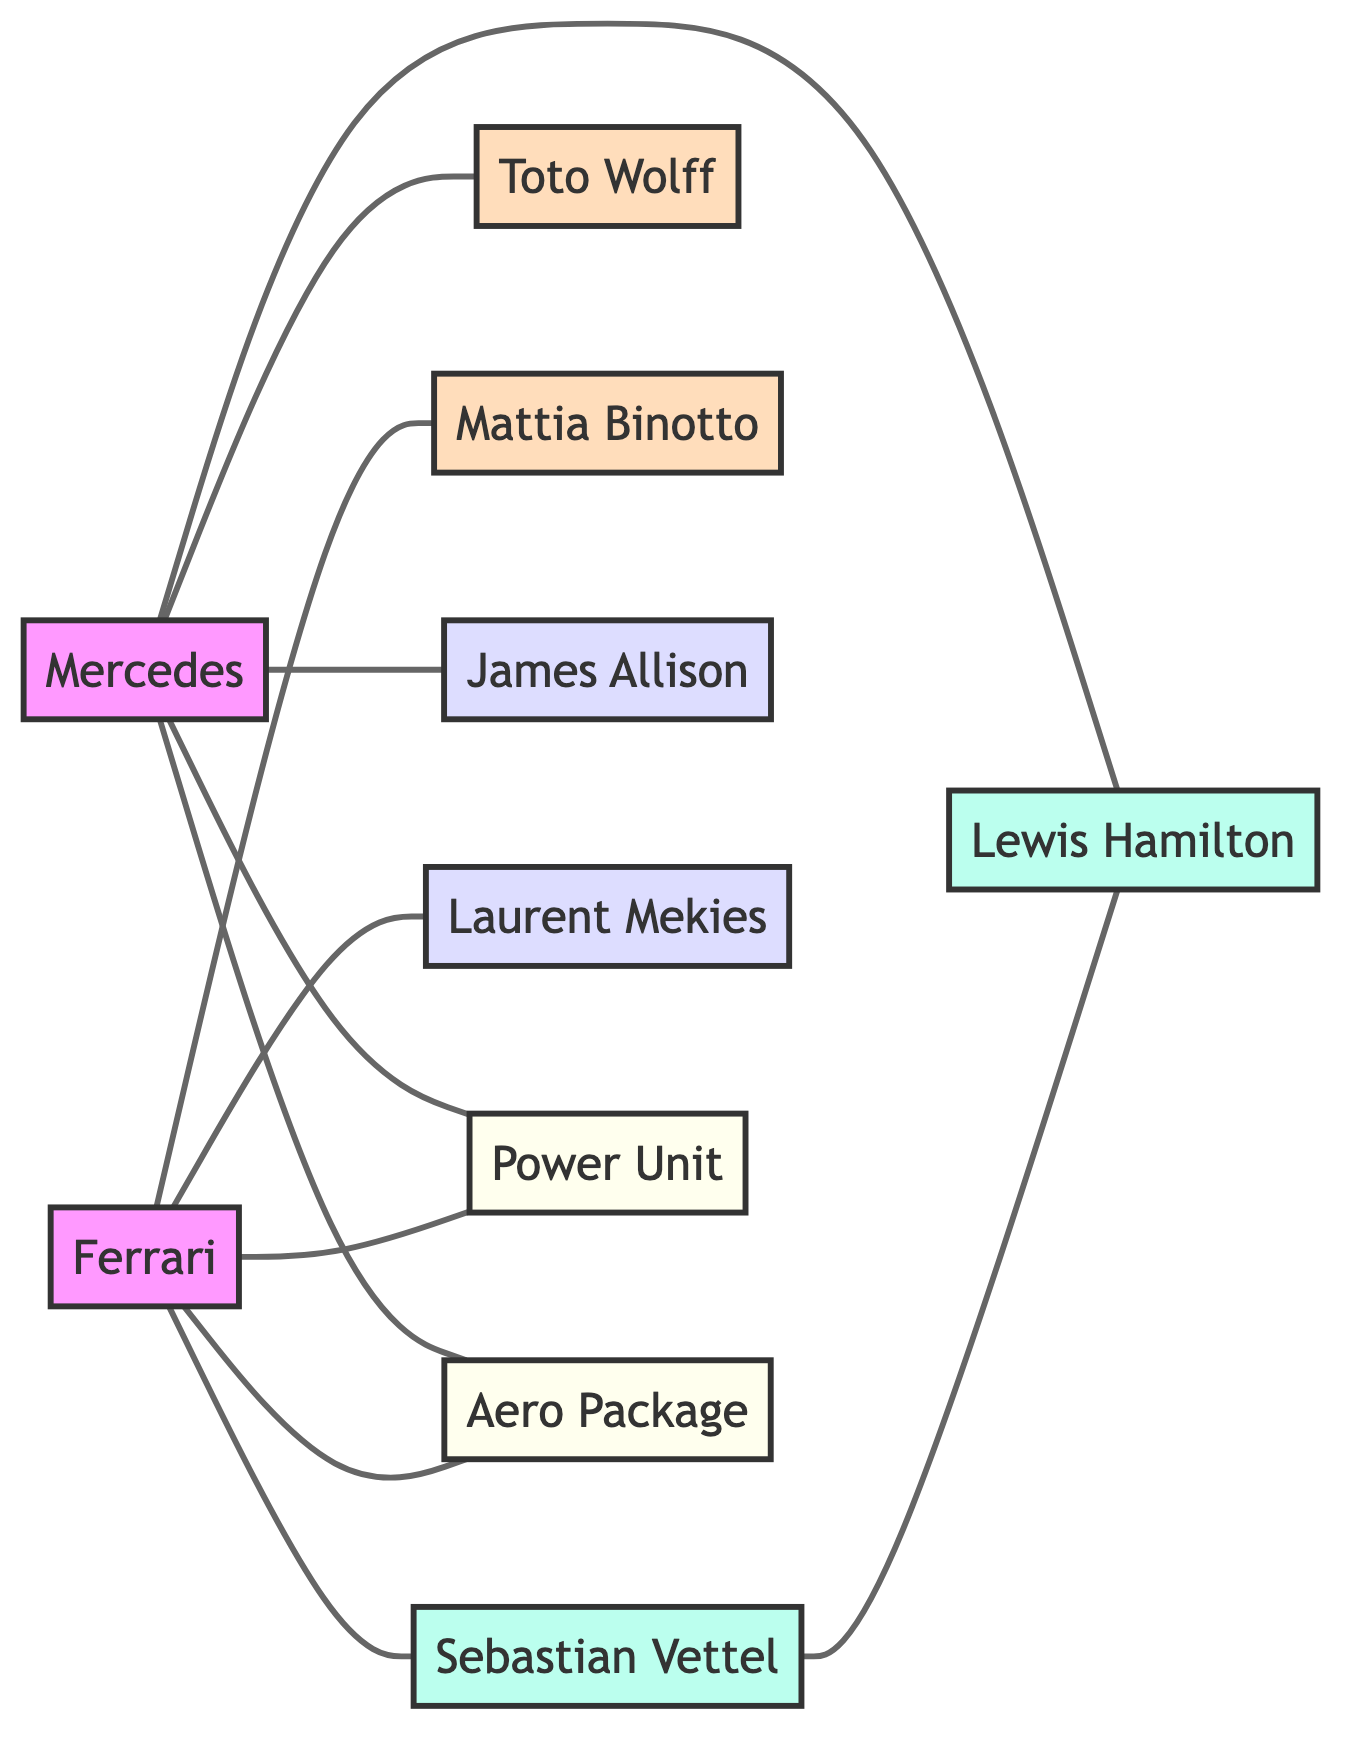What team employs Lewis Hamilton? According to the edges connecting the nodes, there is a direct relationship labeled "employs" from the Mercedes node to the Lewis Hamilton node. Hence, Mercedes is the team that employs Lewis Hamilton.
Answer: Mercedes Who manages Ferrari? The node representing Ferrari has a connecting edge labeled "managed by" to the Mattia Binotto node. This indicates that Mattia Binotto is the manager of Ferrari.
Answer: Mattia Binotto How many total teams are represented in the diagram? The diagram shows two distinct teams, Mercedes and Ferrari, which are both represented as nodes. Therefore, the total number of teams is two.
Answer: 2 Which component is used by both Mercedes and Ferrari? The diagram indicates that both Mercedes and Ferrari have edges labeled "uses" connecting to the Power Unit node. This means that the Power Unit is the shared component used by both teams.
Answer: Power Unit What is the relationship between Lewis Hamilton and Sebastian Vettel? The diagram shows a single edge labeled "competitor" connecting the Sebastian Vettel node to the Lewis Hamilton node. This indicates that the relationship between them is that they are competitors.
Answer: competitor What role does James Allison play at Mercedes? The edges show that James Allison is connected to the Mercedes node with a label "has," which means he holds a position or role within the Mercedes team. Specifically, he is identified as the Technical Director.
Answer: Technical Director Which team has a Sporting Director, and who is it? The Ferrari team has a connection to the Laurent Mekies node labeled "has," indicating that Laurent Mekies serves in the role of Sporting Director for the Ferrari team.
Answer: Ferrari; Laurent Mekies How many edges are connected to the Mercedes node? Counting the edges connected to the Mercedes node, we find it is linked to Lewis Hamilton, Toto Wolff, James Allison, Power Unit, and Aero Package. Thus, there are five edges connected to Mercedes.
Answer: 5 What type of graph is used to represent the relationships in this diagram? Given that the nodes have connections without a specific direction, it is classified as an undirected graph. This means that the relationships are mutual and do not have a direction.
Answer: Undirected Graph 